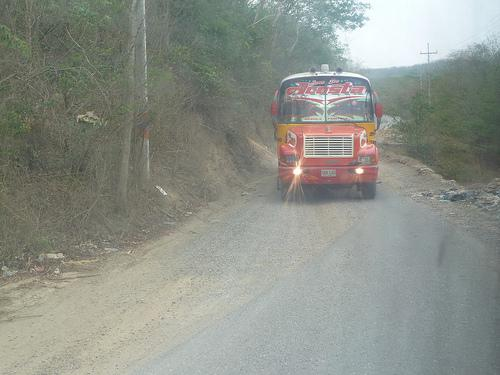Question: what is seen in the picture?
Choices:
A. Bus.
B. Car.
C. Train.
D. Plane.
Answer with the letter. Answer: A Question: what is the color of the leaves?
Choices:
A. Red.
B. Orange.
C. Yellow.
D. Green.
Answer with the letter. Answer: D Question: how many bus?
Choices:
A. 1.
B. 2.
C. 3.
D. 4.
Answer with the letter. Answer: A Question: what is the color of the bus?
Choices:
A. Yellow.
B. Red.
C. White.
D. Grey.
Answer with the letter. Answer: B Question: what is the color of the road?
Choices:
A. Blue.
B. Grey.
C. Red.
D. Green.
Answer with the letter. Answer: B 